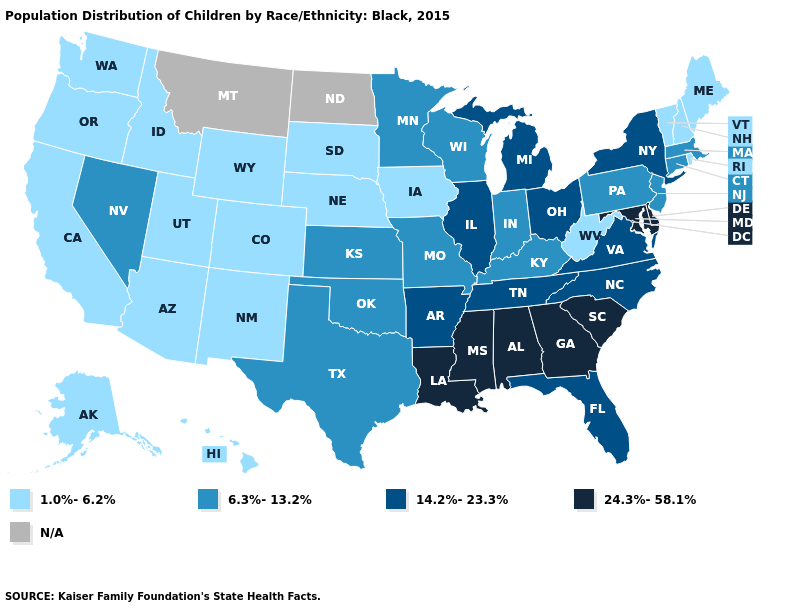Name the states that have a value in the range 24.3%-58.1%?
Short answer required. Alabama, Delaware, Georgia, Louisiana, Maryland, Mississippi, South Carolina. Name the states that have a value in the range 6.3%-13.2%?
Keep it brief. Connecticut, Indiana, Kansas, Kentucky, Massachusetts, Minnesota, Missouri, Nevada, New Jersey, Oklahoma, Pennsylvania, Texas, Wisconsin. What is the value of New Hampshire?
Quick response, please. 1.0%-6.2%. What is the value of Tennessee?
Short answer required. 14.2%-23.3%. What is the highest value in states that border Minnesota?
Give a very brief answer. 6.3%-13.2%. Name the states that have a value in the range N/A?
Give a very brief answer. Montana, North Dakota. What is the value of Georgia?
Keep it brief. 24.3%-58.1%. What is the highest value in states that border Massachusetts?
Concise answer only. 14.2%-23.3%. What is the highest value in states that border Oklahoma?
Quick response, please. 14.2%-23.3%. Name the states that have a value in the range 14.2%-23.3%?
Give a very brief answer. Arkansas, Florida, Illinois, Michigan, New York, North Carolina, Ohio, Tennessee, Virginia. What is the value of Washington?
Keep it brief. 1.0%-6.2%. Which states have the lowest value in the West?
Be succinct. Alaska, Arizona, California, Colorado, Hawaii, Idaho, New Mexico, Oregon, Utah, Washington, Wyoming. What is the lowest value in the West?
Keep it brief. 1.0%-6.2%. Does the first symbol in the legend represent the smallest category?
Keep it brief. Yes. 